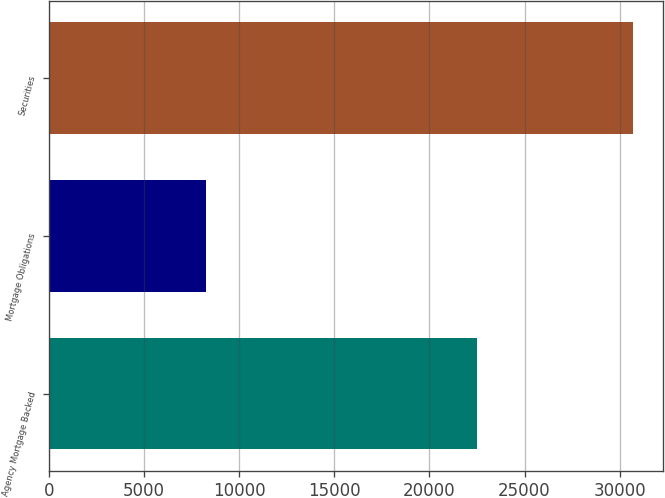<chart> <loc_0><loc_0><loc_500><loc_500><bar_chart><fcel>Agency Mortgage Backed<fcel>Mortgage Obligations<fcel>Securities<nl><fcel>22475<fcel>8244<fcel>30719<nl></chart> 